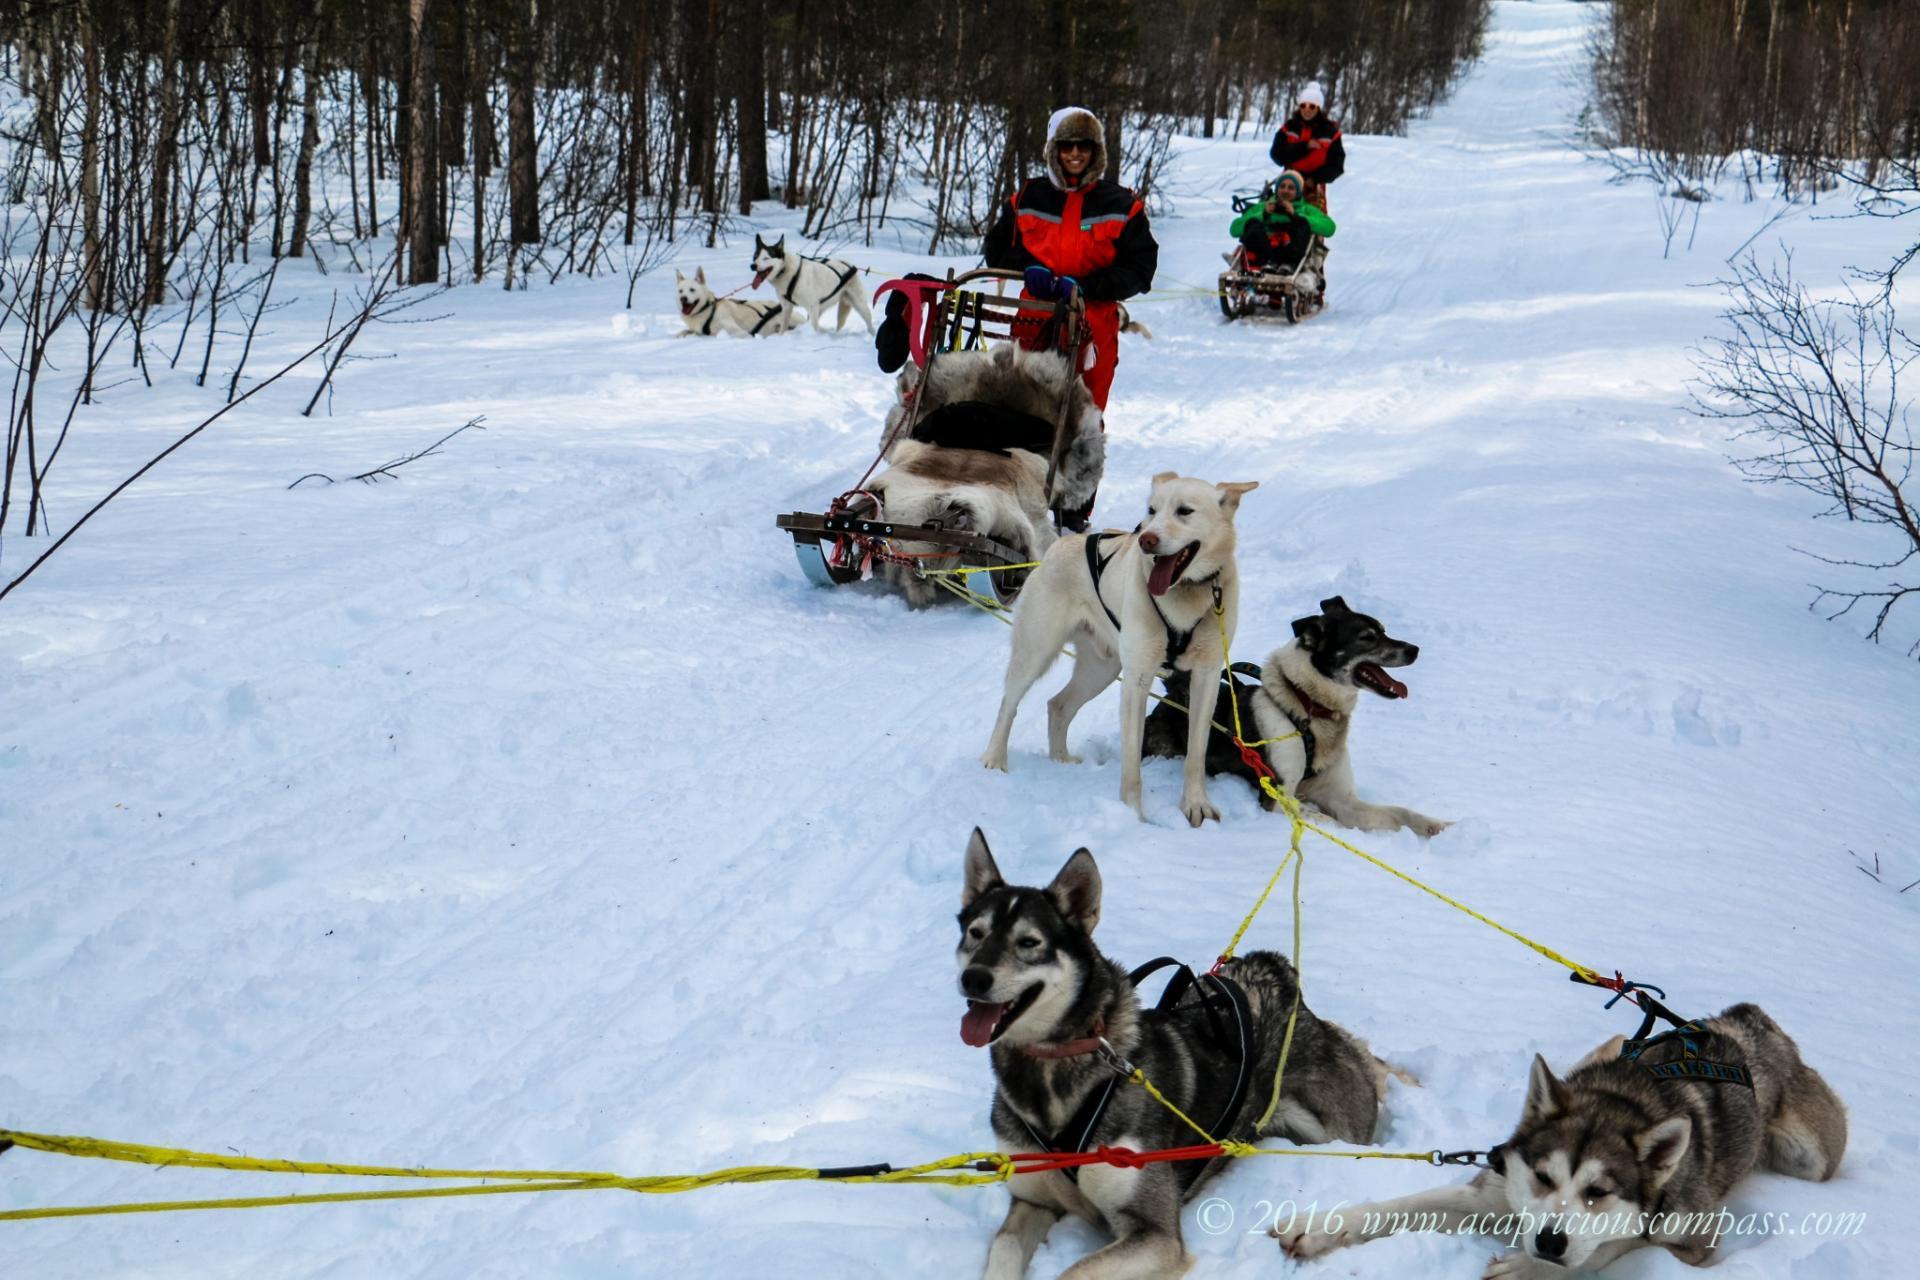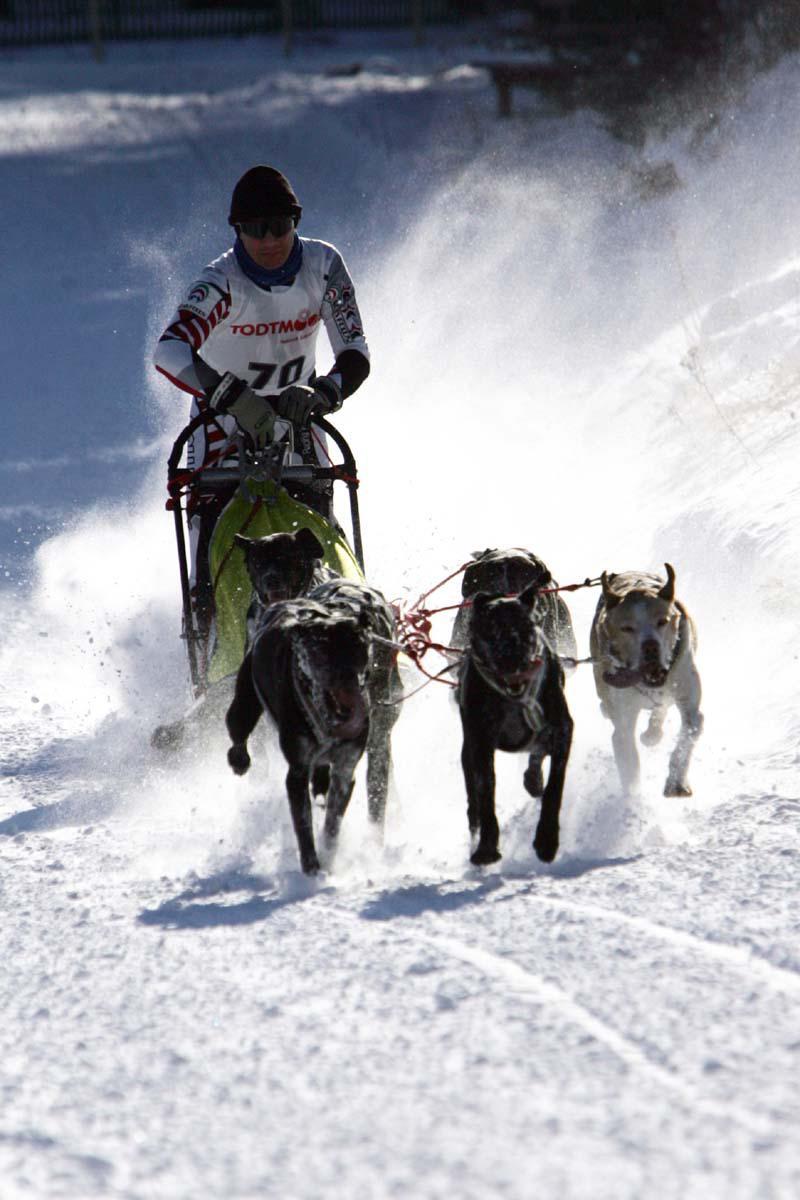The first image is the image on the left, the second image is the image on the right. Given the left and right images, does the statement "There is a person with a red coat in one of the images." hold true? Answer yes or no. Yes. The first image is the image on the left, the second image is the image on the right. Assess this claim about the two images: "All of the dogs are standing and at least some of the dogs are running.". Correct or not? Answer yes or no. No. 